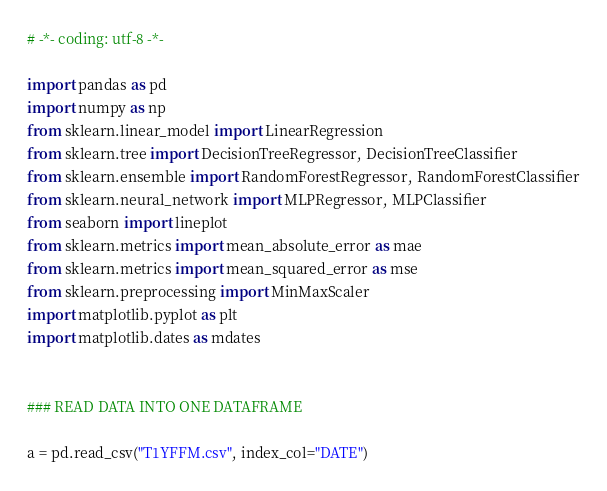Convert code to text. <code><loc_0><loc_0><loc_500><loc_500><_Python_># -*- coding: utf-8 -*-

import pandas as pd
import numpy as np
from sklearn.linear_model import LinearRegression
from sklearn.tree import DecisionTreeRegressor, DecisionTreeClassifier
from sklearn.ensemble import RandomForestRegressor, RandomForestClassifier
from sklearn.neural_network import MLPRegressor, MLPClassifier
from seaborn import lineplot
from sklearn.metrics import mean_absolute_error as mae
from sklearn.metrics import mean_squared_error as mse
from sklearn.preprocessing import MinMaxScaler
import matplotlib.pyplot as plt
import matplotlib.dates as mdates


### READ DATA INTO ONE DATAFRAME

a = pd.read_csv("T1YFFM.csv", index_col="DATE")</code> 